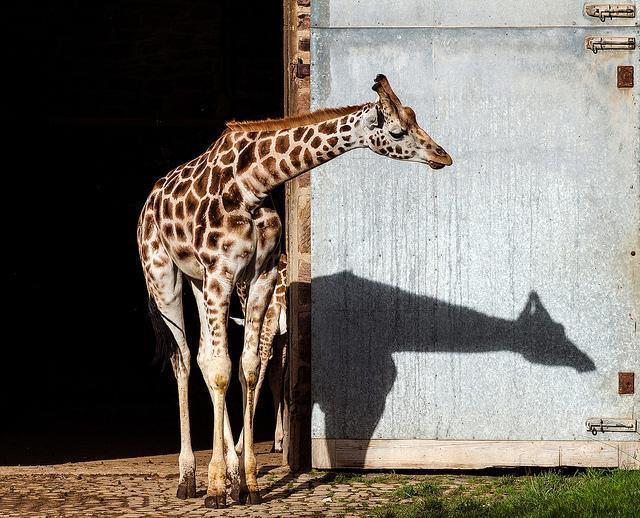How many giraffes are there?
Give a very brief answer. 1. 